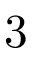Convert formula to latex. <formula><loc_0><loc_0><loc_500><loc_500>3</formula> 